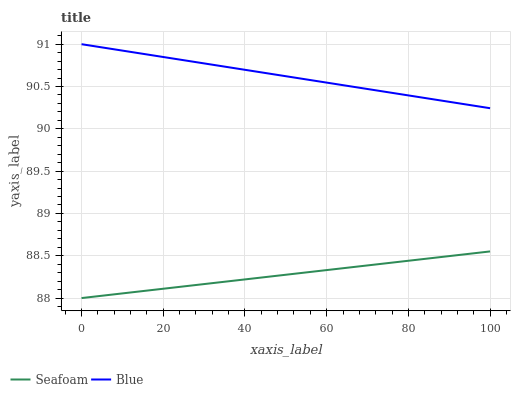Does Seafoam have the maximum area under the curve?
Answer yes or no. No. Is Seafoam the smoothest?
Answer yes or no. No. Does Seafoam have the highest value?
Answer yes or no. No. Is Seafoam less than Blue?
Answer yes or no. Yes. Is Blue greater than Seafoam?
Answer yes or no. Yes. Does Seafoam intersect Blue?
Answer yes or no. No. 